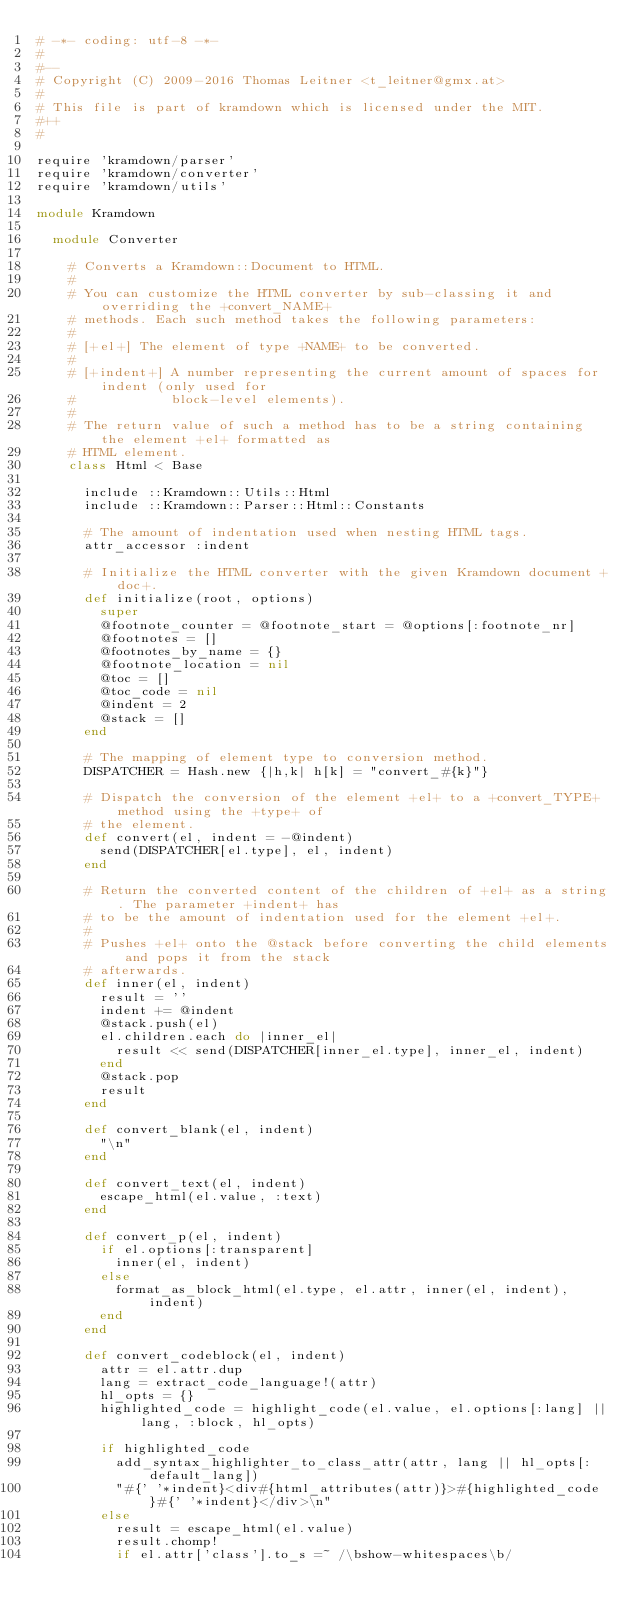<code> <loc_0><loc_0><loc_500><loc_500><_Ruby_># -*- coding: utf-8 -*-
#
#--
# Copyright (C) 2009-2016 Thomas Leitner <t_leitner@gmx.at>
#
# This file is part of kramdown which is licensed under the MIT.
#++
#

require 'kramdown/parser'
require 'kramdown/converter'
require 'kramdown/utils'

module Kramdown

  module Converter

    # Converts a Kramdown::Document to HTML.
    #
    # You can customize the HTML converter by sub-classing it and overriding the +convert_NAME+
    # methods. Each such method takes the following parameters:
    #
    # [+el+] The element of type +NAME+ to be converted.
    #
    # [+indent+] A number representing the current amount of spaces for indent (only used for
    #            block-level elements).
    #
    # The return value of such a method has to be a string containing the element +el+ formatted as
    # HTML element.
    class Html < Base

      include ::Kramdown::Utils::Html
      include ::Kramdown::Parser::Html::Constants

      # The amount of indentation used when nesting HTML tags.
      attr_accessor :indent

      # Initialize the HTML converter with the given Kramdown document +doc+.
      def initialize(root, options)
        super
        @footnote_counter = @footnote_start = @options[:footnote_nr]
        @footnotes = []
        @footnotes_by_name = {}
        @footnote_location = nil
        @toc = []
        @toc_code = nil
        @indent = 2
        @stack = []
      end

      # The mapping of element type to conversion method.
      DISPATCHER = Hash.new {|h,k| h[k] = "convert_#{k}"}

      # Dispatch the conversion of the element +el+ to a +convert_TYPE+ method using the +type+ of
      # the element.
      def convert(el, indent = -@indent)
        send(DISPATCHER[el.type], el, indent)
      end

      # Return the converted content of the children of +el+ as a string. The parameter +indent+ has
      # to be the amount of indentation used for the element +el+.
      #
      # Pushes +el+ onto the @stack before converting the child elements and pops it from the stack
      # afterwards.
      def inner(el, indent)
        result = ''
        indent += @indent
        @stack.push(el)
        el.children.each do |inner_el|
          result << send(DISPATCHER[inner_el.type], inner_el, indent)
        end
        @stack.pop
        result
      end

      def convert_blank(el, indent)
        "\n"
      end

      def convert_text(el, indent)
        escape_html(el.value, :text)
      end

      def convert_p(el, indent)
        if el.options[:transparent]
          inner(el, indent)
        else
          format_as_block_html(el.type, el.attr, inner(el, indent), indent)
        end
      end

      def convert_codeblock(el, indent)
        attr = el.attr.dup
        lang = extract_code_language!(attr)
        hl_opts = {}
        highlighted_code = highlight_code(el.value, el.options[:lang] || lang, :block, hl_opts)

        if highlighted_code
          add_syntax_highlighter_to_class_attr(attr, lang || hl_opts[:default_lang])
          "#{' '*indent}<div#{html_attributes(attr)}>#{highlighted_code}#{' '*indent}</div>\n"
        else
          result = escape_html(el.value)
          result.chomp!
          if el.attr['class'].to_s =~ /\bshow-whitespaces\b/</code> 